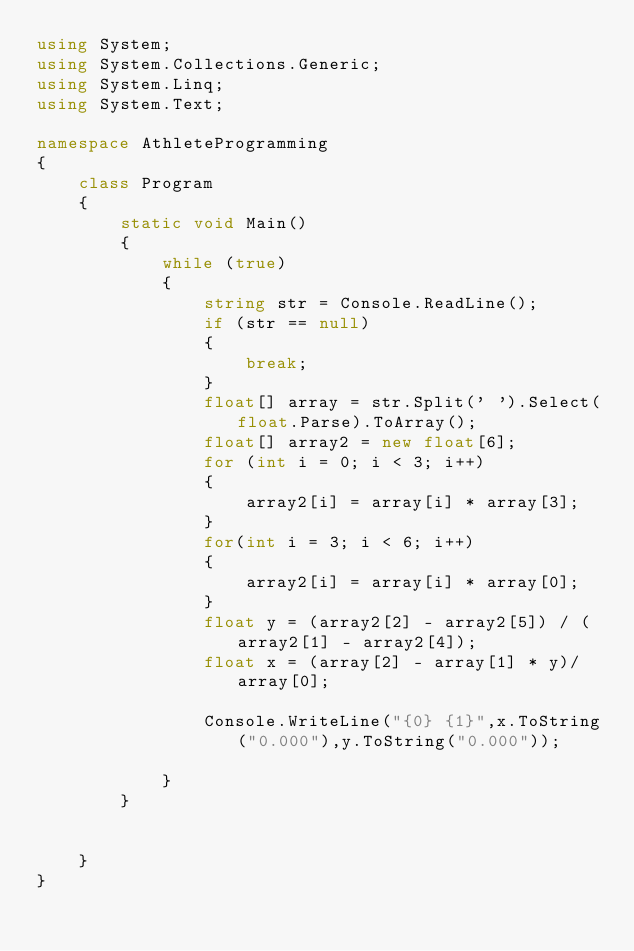Convert code to text. <code><loc_0><loc_0><loc_500><loc_500><_C#_>using System;
using System.Collections.Generic;
using System.Linq;
using System.Text;

namespace AthleteProgramming
{
    class Program
    {
        static void Main()
        {
            while (true)
            {
                string str = Console.ReadLine();
                if (str == null)
                {
                    break;
                }
                float[] array = str.Split(' ').Select(float.Parse).ToArray();
                float[] array2 = new float[6];
                for (int i = 0; i < 3; i++)
                {
                    array2[i] = array[i] * array[3];
                }
                for(int i = 3; i < 6; i++)
                {
                    array2[i] = array[i] * array[0];
                }
                float y = (array2[2] - array2[5]) / (array2[1] - array2[4]);
                float x = (array[2] - array[1] * y)/array[0];

                Console.WriteLine("{0} {1}",x.ToString("0.000"),y.ToString("0.000"));

            }
        }

       
    }
}</code> 